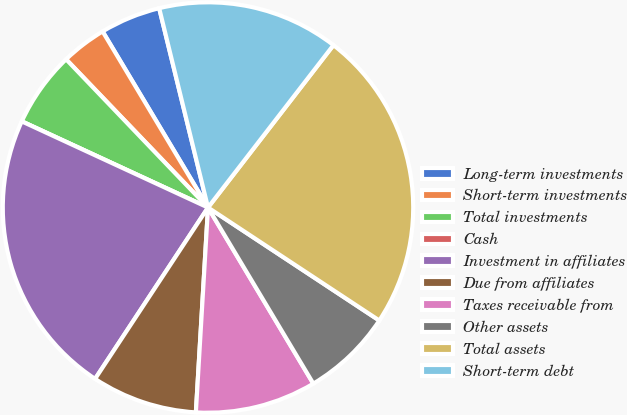Convert chart. <chart><loc_0><loc_0><loc_500><loc_500><pie_chart><fcel>Long-term investments<fcel>Short-term investments<fcel>Total investments<fcel>Cash<fcel>Investment in affiliates<fcel>Due from affiliates<fcel>Taxes receivable from<fcel>Other assets<fcel>Total assets<fcel>Short-term debt<nl><fcel>4.76%<fcel>3.57%<fcel>5.95%<fcel>0.0%<fcel>22.62%<fcel>8.33%<fcel>9.52%<fcel>7.14%<fcel>23.81%<fcel>14.29%<nl></chart> 